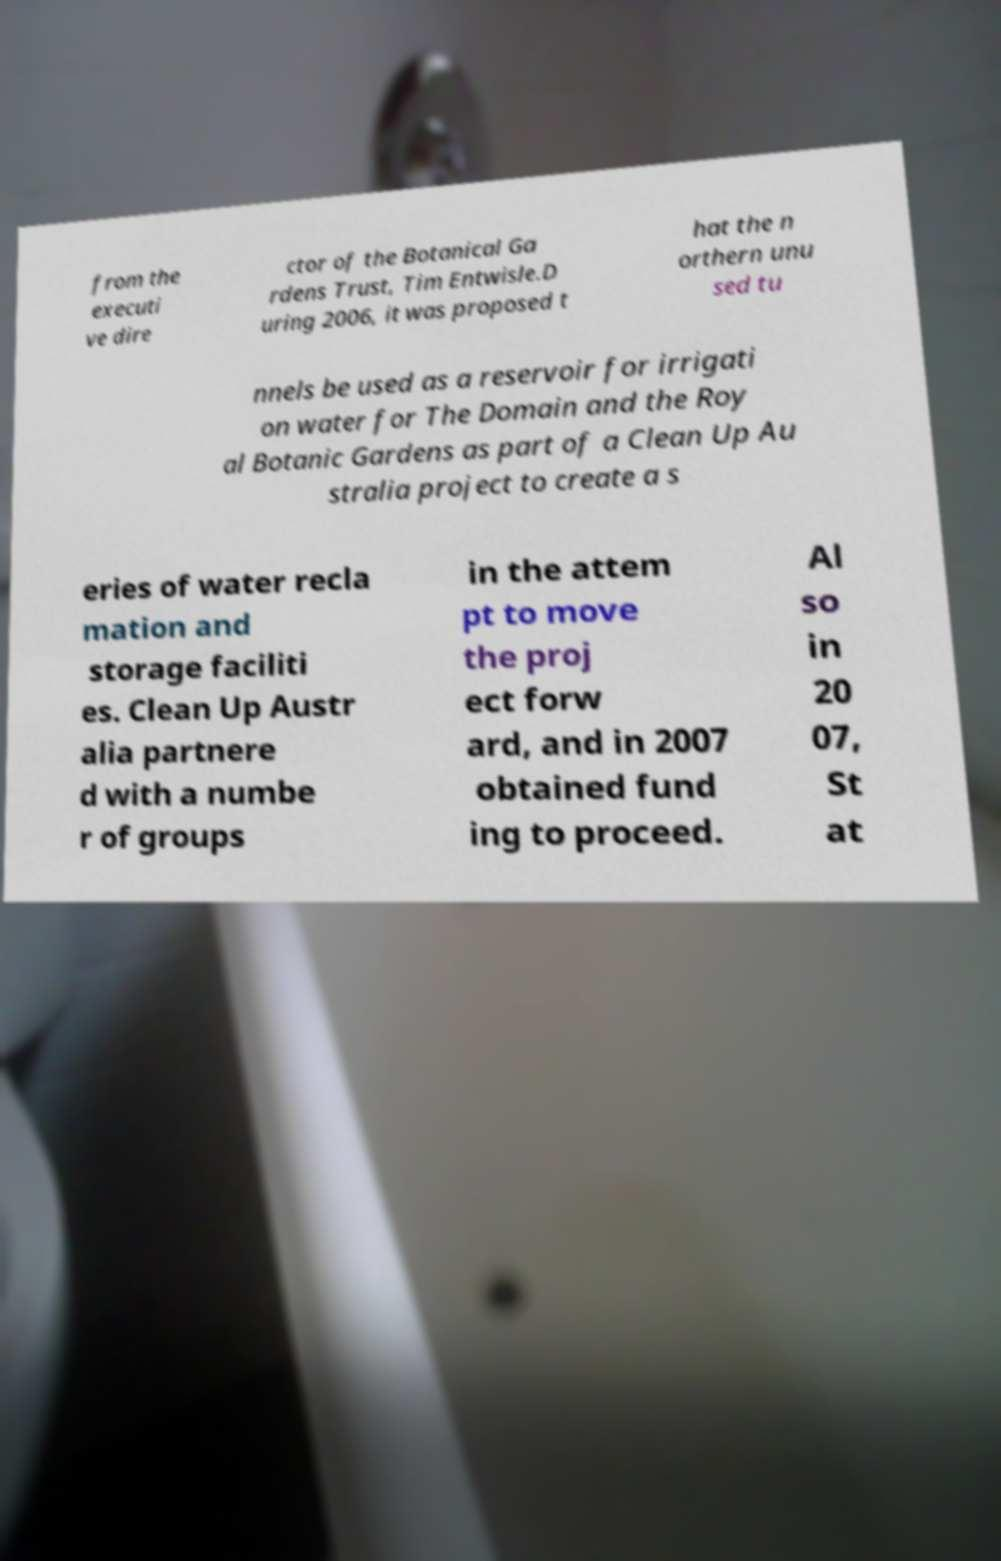Could you assist in decoding the text presented in this image and type it out clearly? from the executi ve dire ctor of the Botanical Ga rdens Trust, Tim Entwisle.D uring 2006, it was proposed t hat the n orthern unu sed tu nnels be used as a reservoir for irrigati on water for The Domain and the Roy al Botanic Gardens as part of a Clean Up Au stralia project to create a s eries of water recla mation and storage faciliti es. Clean Up Austr alia partnere d with a numbe r of groups in the attem pt to move the proj ect forw ard, and in 2007 obtained fund ing to proceed. Al so in 20 07, St at 